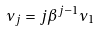Convert formula to latex. <formula><loc_0><loc_0><loc_500><loc_500>\nu _ { j } = j \beta ^ { j - 1 } \nu _ { 1 }</formula> 